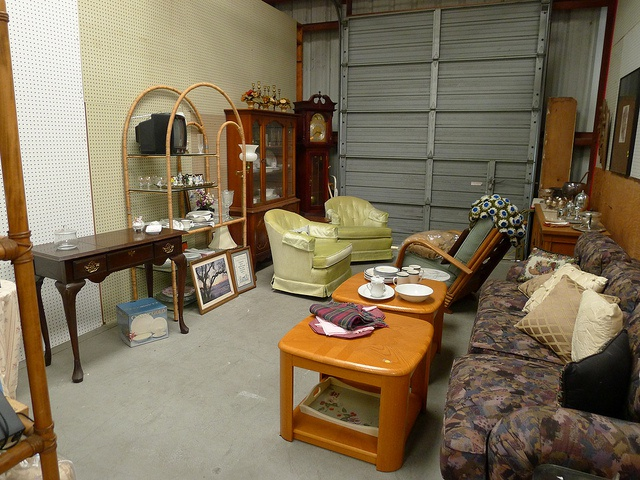Describe the objects in this image and their specific colors. I can see couch in tan, black, gray, and maroon tones, chair in tan, khaki, and olive tones, couch in tan, khaki, and olive tones, chair in tan, black, gray, maroon, and olive tones, and couch in tan, olive, and gray tones in this image. 